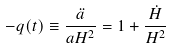<formula> <loc_0><loc_0><loc_500><loc_500>- q ( t ) \equiv \frac { \ddot { a } } { a H ^ { 2 } } = 1 + \frac { \dot { H } } { H ^ { 2 } }</formula> 